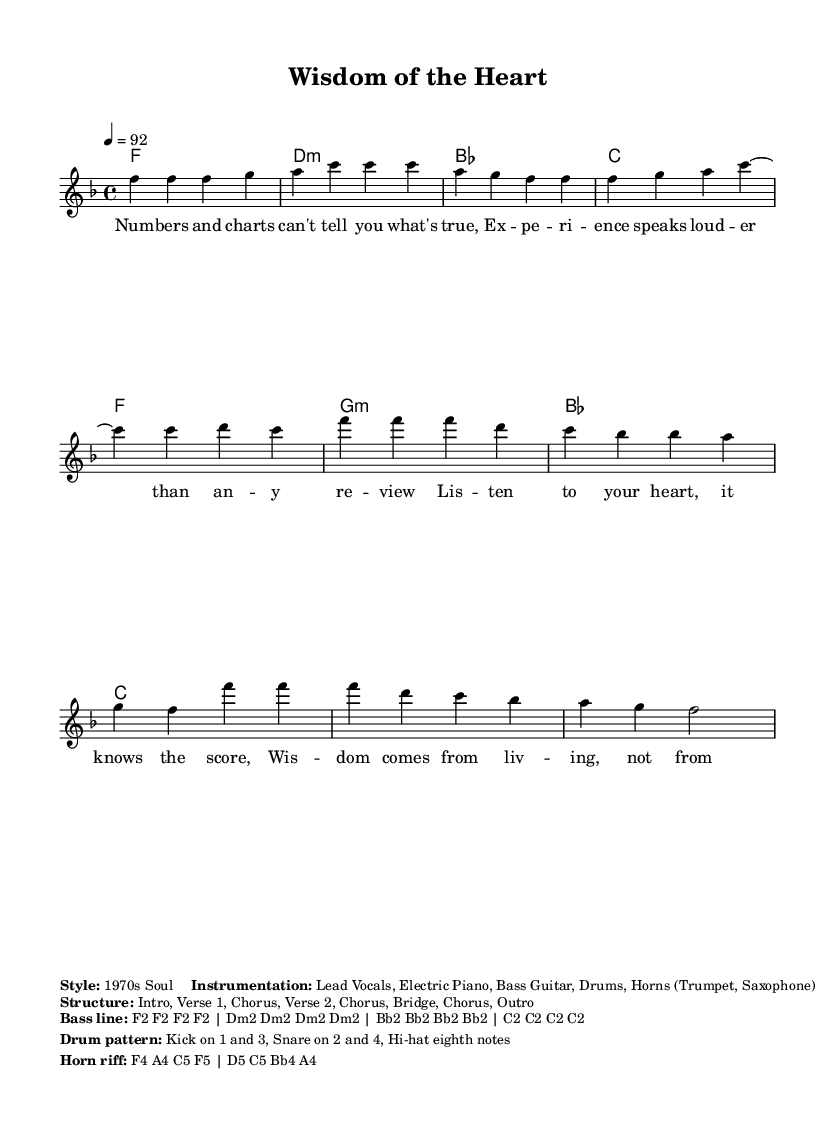What is the key signature of this music? The key signature is indicated at the beginning of the score. It shows one flat, which defines the piece as being in F major.
Answer: F major What is the time signature of this music? The time signature appears at the start of the piece. It is expressed as 4/4, meaning there are four beats in each measure and a quarter note receives one beat.
Answer: 4/4 What is the tempo marking for this music? The tempo is stated at the beginning with the marking "4 = 92". This indicates that the quarter note equals 92 beats per minute.
Answer: 92 How many measures are there in the verse? The verse is composed of specific sequences of notes separated by vertical lines that denote measures. Counting these vertical lines, there are six measures in total in the verse section.
Answer: 6 What instruments are specified for this piece? The information on instrumentation is provided in the markup section of the score, which lists the instruments intended for the performance. The instrumentation includes Lead Vocals, Electric Piano, Bass Guitar, Drums, and Horns.
Answer: Lead Vocals, Electric Piano, Bass Guitar, Drums, Horns What is the structure of the music? The structure is outlined in a separate markup section that details the arrangement of the sections in the piece. It lists the Introduction, Verse 1, Chorus, Verse 2, Chorus, Bridge, Chorus, and Outro.
Answer: Intro, Verse 1, Chorus, Verse 2, Chorus, Bridge, Chorus, Outro What lyrical theme is suggested by the lyrics in the chorus? The theme is interpreted by analyzing the lyrical content of the chorus. The lyrics emphasize listening to one's heart and valuing wisdom gained from life experience over analytical assessments.
Answer: Wisdom from experience 